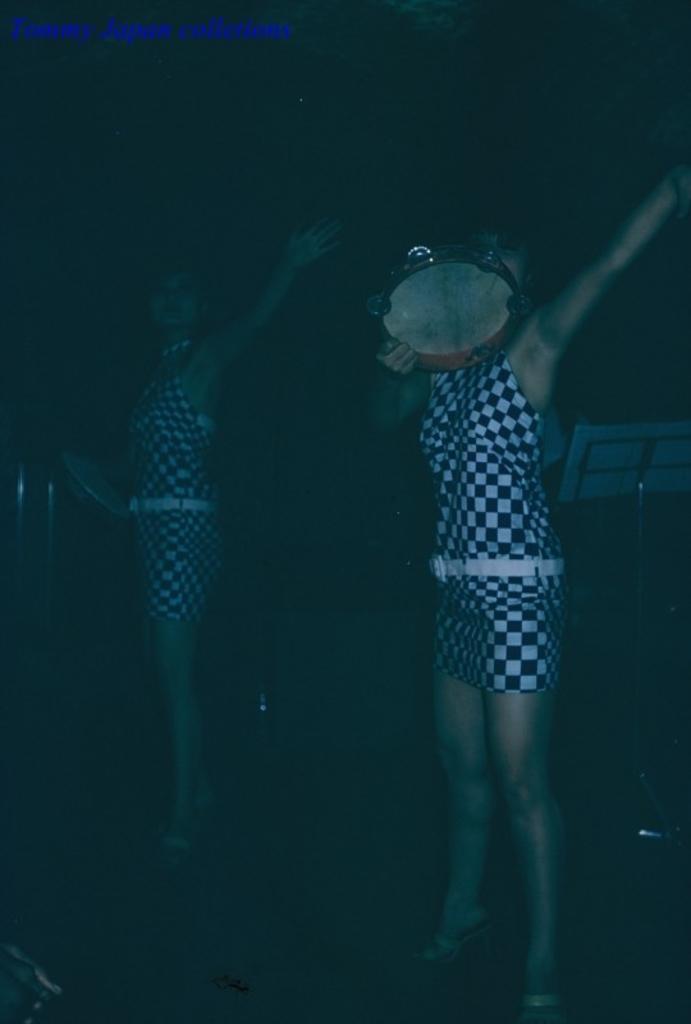How would you summarize this image in a sentence or two? In this picture there are two women standing and holding a musical instrument in their hands and there are some other objects in the background. 